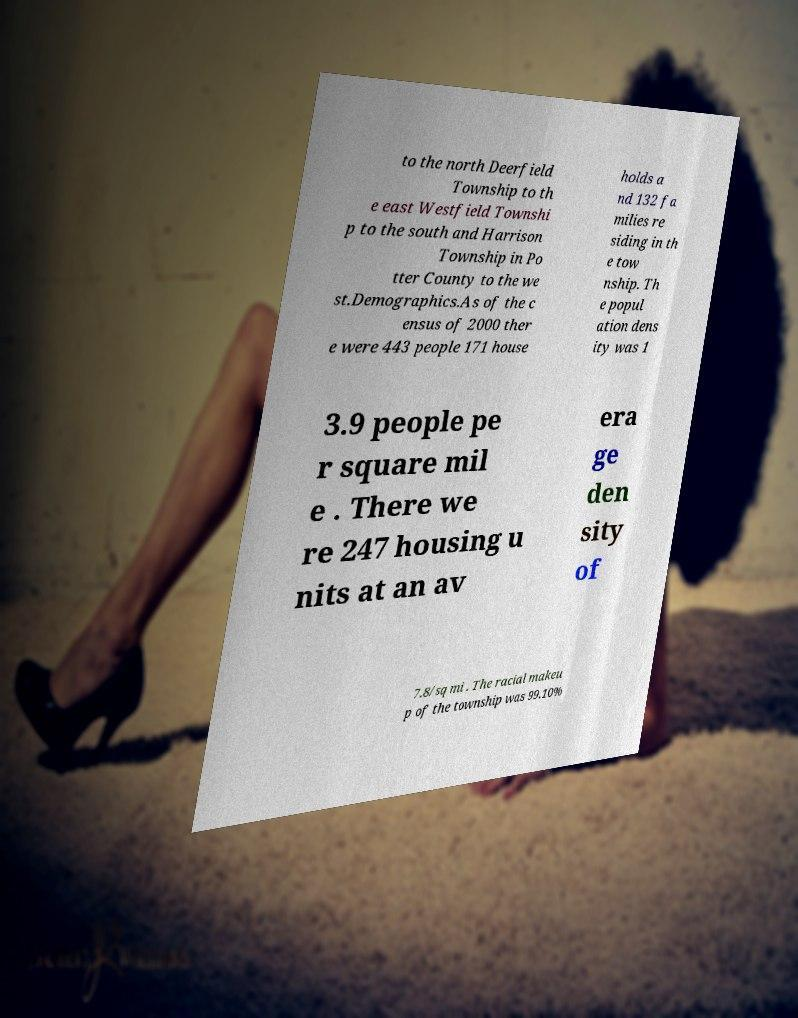There's text embedded in this image that I need extracted. Can you transcribe it verbatim? to the north Deerfield Township to th e east Westfield Townshi p to the south and Harrison Township in Po tter County to the we st.Demographics.As of the c ensus of 2000 ther e were 443 people 171 house holds a nd 132 fa milies re siding in th e tow nship. Th e popul ation dens ity was 1 3.9 people pe r square mil e . There we re 247 housing u nits at an av era ge den sity of 7.8/sq mi . The racial makeu p of the township was 99.10% 